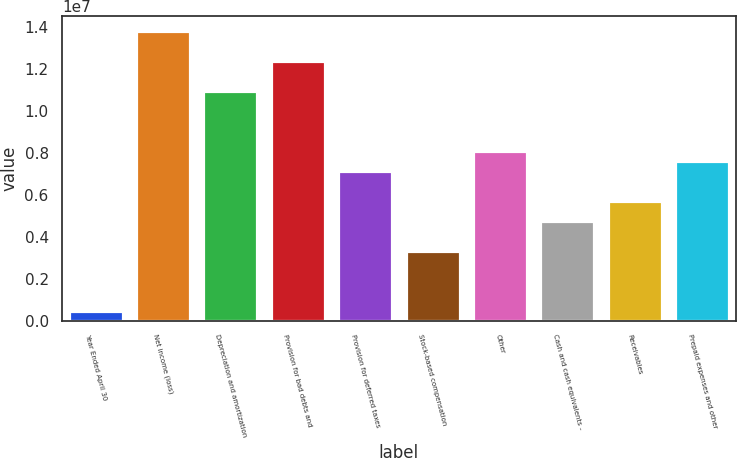<chart> <loc_0><loc_0><loc_500><loc_500><bar_chart><fcel>Year Ended April 30<fcel>Net income (loss)<fcel>Depreciation and amortization<fcel>Provision for bad debts and<fcel>Provision for deferred taxes<fcel>Stock-based compensation<fcel>Other<fcel>Cash and cash equivalents -<fcel>Receivables<fcel>Prepaid expenses and other<nl><fcel>477663<fcel>1.38076e+07<fcel>1.09512e+07<fcel>1.23794e+07<fcel>7.14264e+06<fcel>3.33408e+06<fcel>8.09478e+06<fcel>4.76229e+06<fcel>5.71443e+06<fcel>7.61871e+06<nl></chart> 